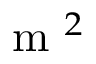<formula> <loc_0><loc_0><loc_500><loc_500>m ^ { 2 }</formula> 